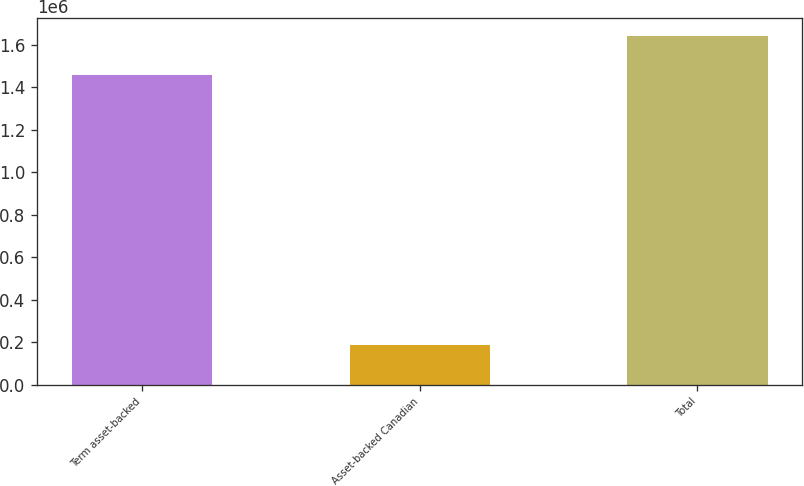<chart> <loc_0><loc_0><loc_500><loc_500><bar_chart><fcel>Term asset-backed<fcel>Asset-backed Canadian<fcel>Total<nl><fcel>1.4586e+06<fcel>185099<fcel>1.6437e+06<nl></chart> 